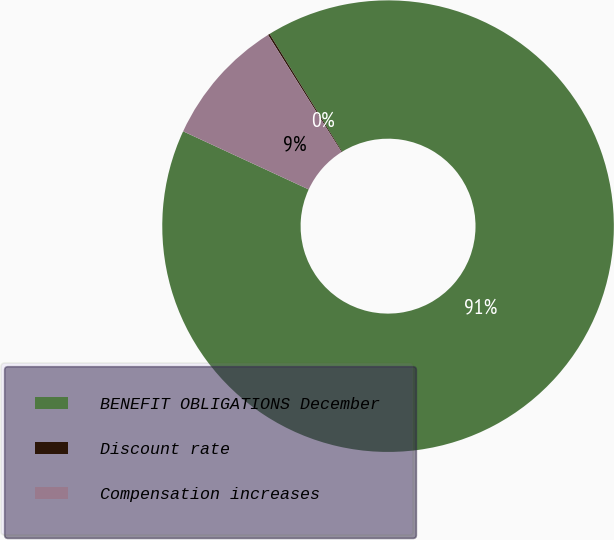Convert chart to OTSL. <chart><loc_0><loc_0><loc_500><loc_500><pie_chart><fcel>BENEFIT OBLIGATIONS December<fcel>Discount rate<fcel>Compensation increases<nl><fcel>90.69%<fcel>0.13%<fcel>9.18%<nl></chart> 